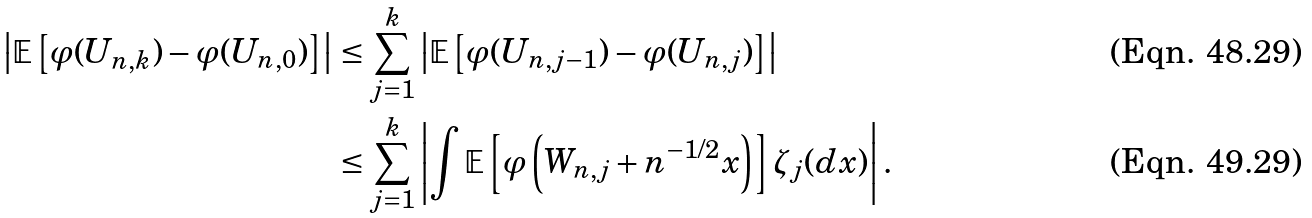Convert formula to latex. <formula><loc_0><loc_0><loc_500><loc_500>\left | \mathbb { E } \left [ \varphi ( U _ { n , k } ) - \varphi ( U _ { n , 0 } ) \right ] \right | & \leq \sum _ { j = 1 } ^ { k } \left | \mathbb { E } \left [ \varphi ( { U _ { n , j - 1 } } ) - \varphi ( U _ { n , j } ) \right ] \right | \\ & \leq \sum _ { j = 1 } ^ { k } \left | \int \mathbb { E } \left [ \varphi \left ( W _ { n , j } + n ^ { - 1 / 2 } x \right ) \right ] \zeta _ { j } ( d x ) \right | .</formula> 